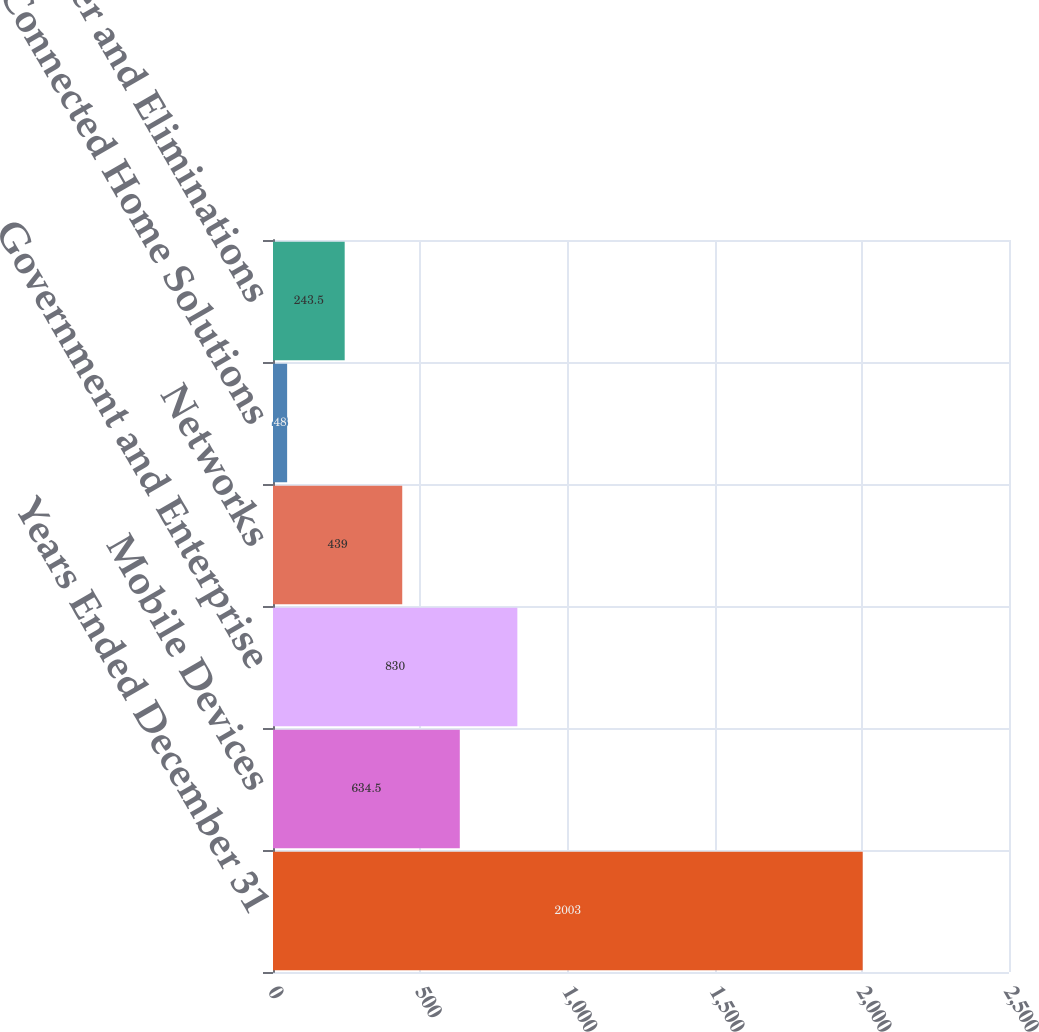Convert chart to OTSL. <chart><loc_0><loc_0><loc_500><loc_500><bar_chart><fcel>Years Ended December 31<fcel>Mobile Devices<fcel>Government and Enterprise<fcel>Networks<fcel>Connected Home Solutions<fcel>Other and Eliminations<nl><fcel>2003<fcel>634.5<fcel>830<fcel>439<fcel>48<fcel>243.5<nl></chart> 